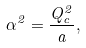<formula> <loc_0><loc_0><loc_500><loc_500>\alpha ^ { 2 } = { \frac { Q _ { c } ^ { 2 } } { a } } ,</formula> 